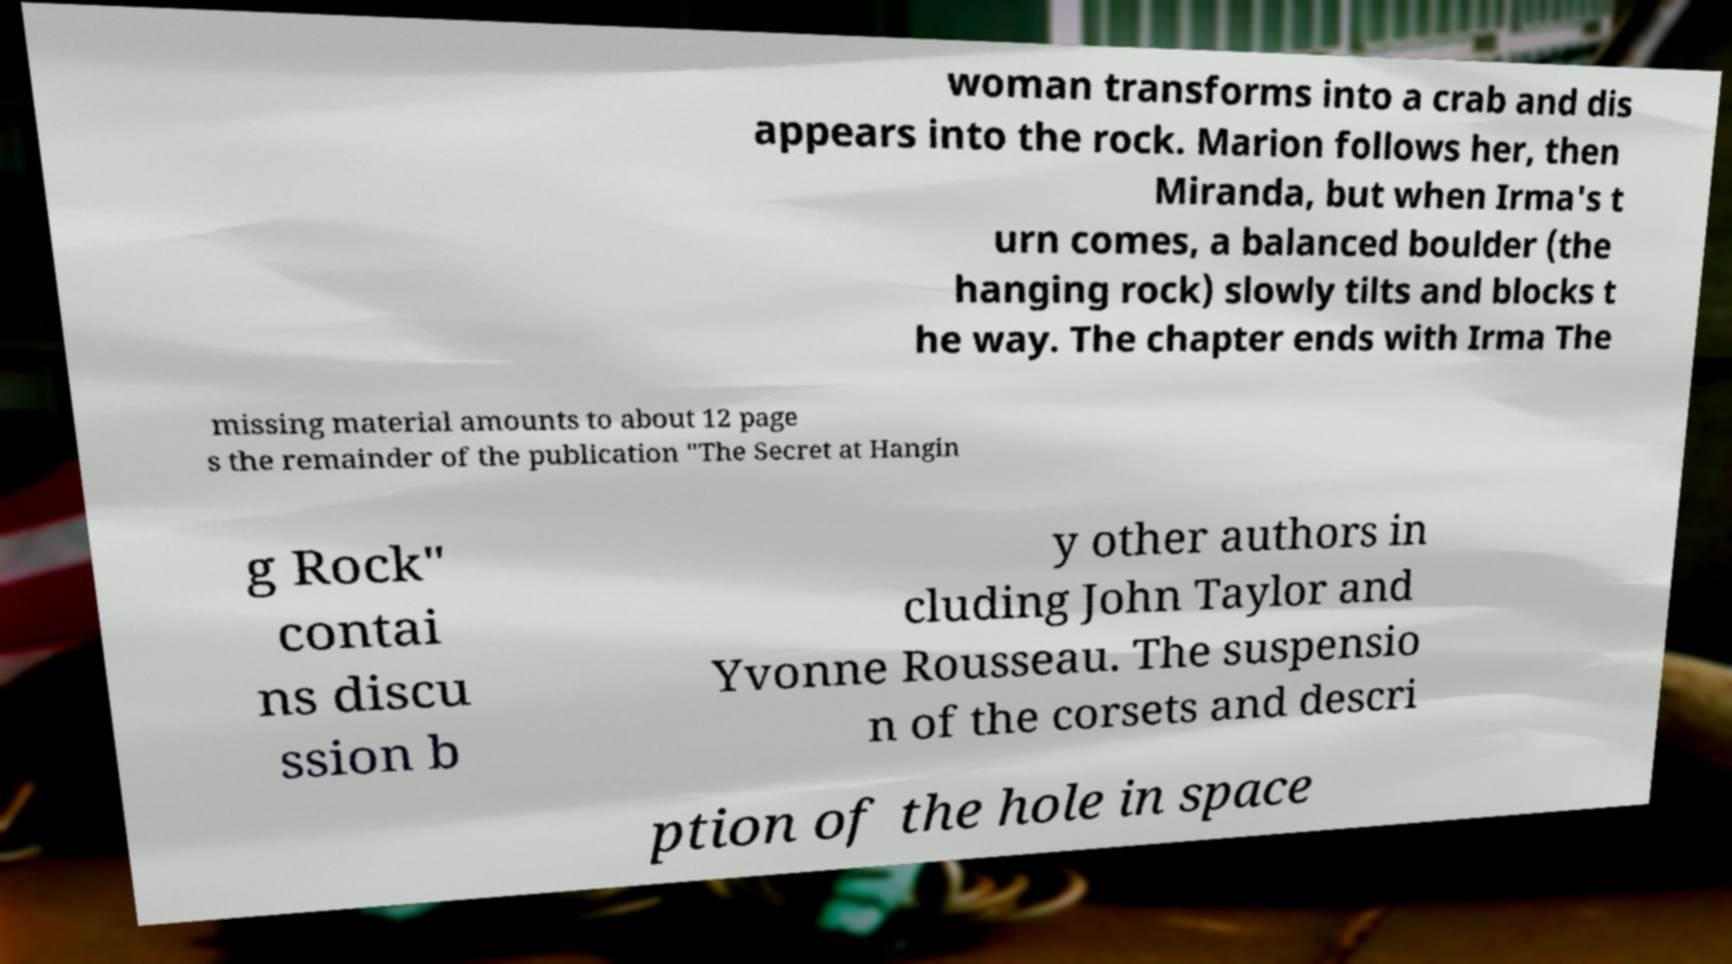There's text embedded in this image that I need extracted. Can you transcribe it verbatim? woman transforms into a crab and dis appears into the rock. Marion follows her, then Miranda, but when Irma's t urn comes, a balanced boulder (the hanging rock) slowly tilts and blocks t he way. The chapter ends with Irma The missing material amounts to about 12 page s the remainder of the publication "The Secret at Hangin g Rock" contai ns discu ssion b y other authors in cluding John Taylor and Yvonne Rousseau. The suspensio n of the corsets and descri ption of the hole in space 